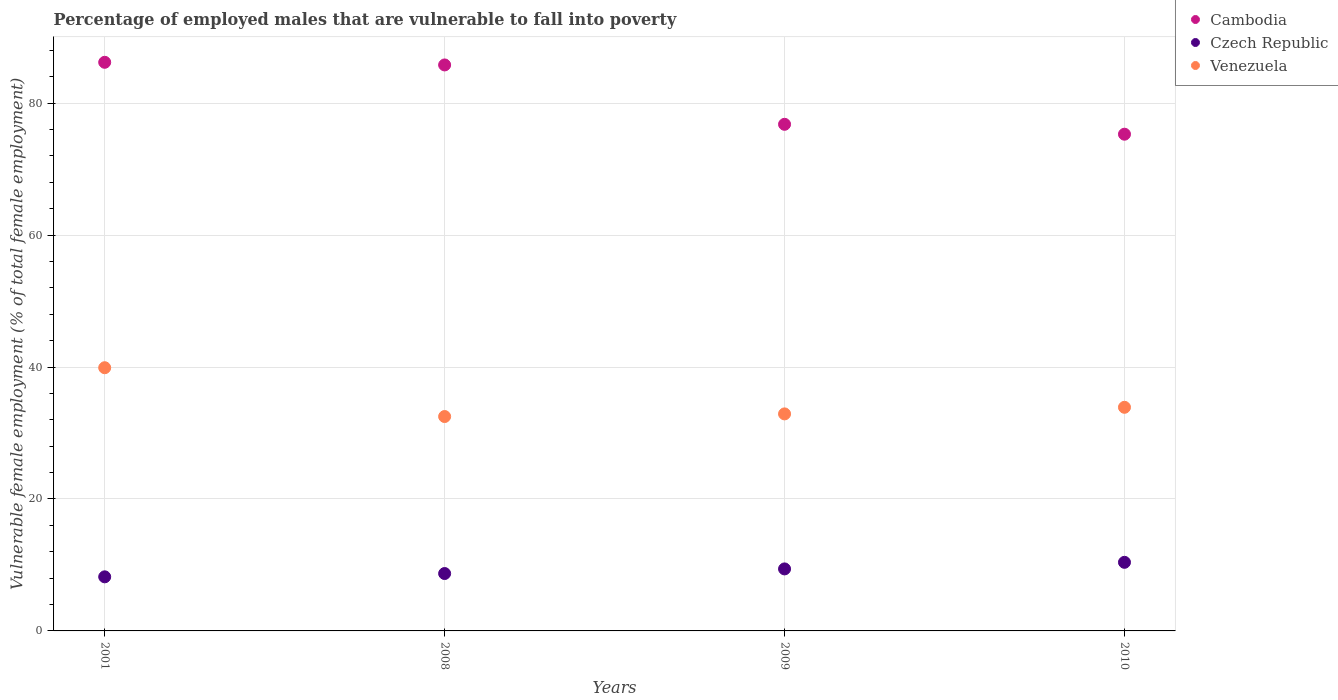What is the percentage of employed males who are vulnerable to fall into poverty in Cambodia in 2008?
Provide a succinct answer. 85.8. Across all years, what is the maximum percentage of employed males who are vulnerable to fall into poverty in Czech Republic?
Provide a succinct answer. 10.4. Across all years, what is the minimum percentage of employed males who are vulnerable to fall into poverty in Venezuela?
Offer a terse response. 32.5. In which year was the percentage of employed males who are vulnerable to fall into poverty in Cambodia minimum?
Offer a very short reply. 2010. What is the total percentage of employed males who are vulnerable to fall into poverty in Cambodia in the graph?
Keep it short and to the point. 324.1. What is the difference between the percentage of employed males who are vulnerable to fall into poverty in Venezuela in 2008 and that in 2009?
Make the answer very short. -0.4. What is the difference between the percentage of employed males who are vulnerable to fall into poverty in Czech Republic in 2010 and the percentage of employed males who are vulnerable to fall into poverty in Venezuela in 2008?
Provide a short and direct response. -22.1. What is the average percentage of employed males who are vulnerable to fall into poverty in Cambodia per year?
Your response must be concise. 81.03. In the year 2010, what is the difference between the percentage of employed males who are vulnerable to fall into poverty in Cambodia and percentage of employed males who are vulnerable to fall into poverty in Czech Republic?
Offer a terse response. 64.9. What is the ratio of the percentage of employed males who are vulnerable to fall into poverty in Cambodia in 2001 to that in 2010?
Ensure brevity in your answer.  1.14. Is the percentage of employed males who are vulnerable to fall into poverty in Cambodia in 2008 less than that in 2010?
Make the answer very short. No. What is the difference between the highest and the second highest percentage of employed males who are vulnerable to fall into poverty in Czech Republic?
Provide a short and direct response. 1. What is the difference between the highest and the lowest percentage of employed males who are vulnerable to fall into poverty in Czech Republic?
Give a very brief answer. 2.2. In how many years, is the percentage of employed males who are vulnerable to fall into poverty in Venezuela greater than the average percentage of employed males who are vulnerable to fall into poverty in Venezuela taken over all years?
Your answer should be very brief. 1. Is the sum of the percentage of employed males who are vulnerable to fall into poverty in Venezuela in 2001 and 2010 greater than the maximum percentage of employed males who are vulnerable to fall into poverty in Czech Republic across all years?
Offer a terse response. Yes. Is the percentage of employed males who are vulnerable to fall into poverty in Cambodia strictly less than the percentage of employed males who are vulnerable to fall into poverty in Czech Republic over the years?
Provide a short and direct response. No. How many dotlines are there?
Provide a short and direct response. 3. How many years are there in the graph?
Your answer should be very brief. 4. What is the difference between two consecutive major ticks on the Y-axis?
Give a very brief answer. 20. Are the values on the major ticks of Y-axis written in scientific E-notation?
Your answer should be very brief. No. Does the graph contain any zero values?
Your response must be concise. No. Does the graph contain grids?
Your response must be concise. Yes. Where does the legend appear in the graph?
Make the answer very short. Top right. How many legend labels are there?
Your answer should be compact. 3. How are the legend labels stacked?
Make the answer very short. Vertical. What is the title of the graph?
Your response must be concise. Percentage of employed males that are vulnerable to fall into poverty. What is the label or title of the X-axis?
Provide a short and direct response. Years. What is the label or title of the Y-axis?
Ensure brevity in your answer.  Vulnerable female employment (% of total female employment). What is the Vulnerable female employment (% of total female employment) in Cambodia in 2001?
Provide a succinct answer. 86.2. What is the Vulnerable female employment (% of total female employment) of Czech Republic in 2001?
Offer a terse response. 8.2. What is the Vulnerable female employment (% of total female employment) of Venezuela in 2001?
Your answer should be very brief. 39.9. What is the Vulnerable female employment (% of total female employment) in Cambodia in 2008?
Your answer should be compact. 85.8. What is the Vulnerable female employment (% of total female employment) of Czech Republic in 2008?
Make the answer very short. 8.7. What is the Vulnerable female employment (% of total female employment) of Venezuela in 2008?
Give a very brief answer. 32.5. What is the Vulnerable female employment (% of total female employment) in Cambodia in 2009?
Make the answer very short. 76.8. What is the Vulnerable female employment (% of total female employment) in Czech Republic in 2009?
Provide a short and direct response. 9.4. What is the Vulnerable female employment (% of total female employment) in Venezuela in 2009?
Your answer should be compact. 32.9. What is the Vulnerable female employment (% of total female employment) in Cambodia in 2010?
Provide a succinct answer. 75.3. What is the Vulnerable female employment (% of total female employment) in Czech Republic in 2010?
Your response must be concise. 10.4. What is the Vulnerable female employment (% of total female employment) of Venezuela in 2010?
Your answer should be very brief. 33.9. Across all years, what is the maximum Vulnerable female employment (% of total female employment) in Cambodia?
Your response must be concise. 86.2. Across all years, what is the maximum Vulnerable female employment (% of total female employment) of Czech Republic?
Keep it short and to the point. 10.4. Across all years, what is the maximum Vulnerable female employment (% of total female employment) of Venezuela?
Your response must be concise. 39.9. Across all years, what is the minimum Vulnerable female employment (% of total female employment) in Cambodia?
Make the answer very short. 75.3. Across all years, what is the minimum Vulnerable female employment (% of total female employment) of Czech Republic?
Keep it short and to the point. 8.2. Across all years, what is the minimum Vulnerable female employment (% of total female employment) in Venezuela?
Keep it short and to the point. 32.5. What is the total Vulnerable female employment (% of total female employment) in Cambodia in the graph?
Ensure brevity in your answer.  324.1. What is the total Vulnerable female employment (% of total female employment) of Czech Republic in the graph?
Provide a succinct answer. 36.7. What is the total Vulnerable female employment (% of total female employment) of Venezuela in the graph?
Offer a terse response. 139.2. What is the difference between the Vulnerable female employment (% of total female employment) in Czech Republic in 2001 and that in 2008?
Provide a short and direct response. -0.5. What is the difference between the Vulnerable female employment (% of total female employment) in Venezuela in 2001 and that in 2008?
Offer a terse response. 7.4. What is the difference between the Vulnerable female employment (% of total female employment) in Cambodia in 2001 and that in 2009?
Make the answer very short. 9.4. What is the difference between the Vulnerable female employment (% of total female employment) of Venezuela in 2001 and that in 2009?
Offer a very short reply. 7. What is the difference between the Vulnerable female employment (% of total female employment) of Cambodia in 2001 and that in 2010?
Your answer should be very brief. 10.9. What is the difference between the Vulnerable female employment (% of total female employment) of Czech Republic in 2001 and that in 2010?
Make the answer very short. -2.2. What is the difference between the Vulnerable female employment (% of total female employment) of Venezuela in 2001 and that in 2010?
Offer a very short reply. 6. What is the difference between the Vulnerable female employment (% of total female employment) of Cambodia in 2008 and that in 2009?
Provide a succinct answer. 9. What is the difference between the Vulnerable female employment (% of total female employment) of Cambodia in 2008 and that in 2010?
Make the answer very short. 10.5. What is the difference between the Vulnerable female employment (% of total female employment) in Czech Republic in 2008 and that in 2010?
Keep it short and to the point. -1.7. What is the difference between the Vulnerable female employment (% of total female employment) in Venezuela in 2008 and that in 2010?
Keep it short and to the point. -1.4. What is the difference between the Vulnerable female employment (% of total female employment) of Cambodia in 2009 and that in 2010?
Provide a short and direct response. 1.5. What is the difference between the Vulnerable female employment (% of total female employment) in Czech Republic in 2009 and that in 2010?
Make the answer very short. -1. What is the difference between the Vulnerable female employment (% of total female employment) of Venezuela in 2009 and that in 2010?
Provide a short and direct response. -1. What is the difference between the Vulnerable female employment (% of total female employment) of Cambodia in 2001 and the Vulnerable female employment (% of total female employment) of Czech Republic in 2008?
Give a very brief answer. 77.5. What is the difference between the Vulnerable female employment (% of total female employment) in Cambodia in 2001 and the Vulnerable female employment (% of total female employment) in Venezuela in 2008?
Provide a succinct answer. 53.7. What is the difference between the Vulnerable female employment (% of total female employment) in Czech Republic in 2001 and the Vulnerable female employment (% of total female employment) in Venezuela in 2008?
Your response must be concise. -24.3. What is the difference between the Vulnerable female employment (% of total female employment) of Cambodia in 2001 and the Vulnerable female employment (% of total female employment) of Czech Republic in 2009?
Offer a very short reply. 76.8. What is the difference between the Vulnerable female employment (% of total female employment) in Cambodia in 2001 and the Vulnerable female employment (% of total female employment) in Venezuela in 2009?
Your answer should be very brief. 53.3. What is the difference between the Vulnerable female employment (% of total female employment) of Czech Republic in 2001 and the Vulnerable female employment (% of total female employment) of Venezuela in 2009?
Your response must be concise. -24.7. What is the difference between the Vulnerable female employment (% of total female employment) of Cambodia in 2001 and the Vulnerable female employment (% of total female employment) of Czech Republic in 2010?
Offer a terse response. 75.8. What is the difference between the Vulnerable female employment (% of total female employment) in Cambodia in 2001 and the Vulnerable female employment (% of total female employment) in Venezuela in 2010?
Offer a terse response. 52.3. What is the difference between the Vulnerable female employment (% of total female employment) of Czech Republic in 2001 and the Vulnerable female employment (% of total female employment) of Venezuela in 2010?
Your answer should be compact. -25.7. What is the difference between the Vulnerable female employment (% of total female employment) in Cambodia in 2008 and the Vulnerable female employment (% of total female employment) in Czech Republic in 2009?
Offer a terse response. 76.4. What is the difference between the Vulnerable female employment (% of total female employment) of Cambodia in 2008 and the Vulnerable female employment (% of total female employment) of Venezuela in 2009?
Make the answer very short. 52.9. What is the difference between the Vulnerable female employment (% of total female employment) of Czech Republic in 2008 and the Vulnerable female employment (% of total female employment) of Venezuela in 2009?
Keep it short and to the point. -24.2. What is the difference between the Vulnerable female employment (% of total female employment) of Cambodia in 2008 and the Vulnerable female employment (% of total female employment) of Czech Republic in 2010?
Provide a short and direct response. 75.4. What is the difference between the Vulnerable female employment (% of total female employment) of Cambodia in 2008 and the Vulnerable female employment (% of total female employment) of Venezuela in 2010?
Give a very brief answer. 51.9. What is the difference between the Vulnerable female employment (% of total female employment) of Czech Republic in 2008 and the Vulnerable female employment (% of total female employment) of Venezuela in 2010?
Ensure brevity in your answer.  -25.2. What is the difference between the Vulnerable female employment (% of total female employment) in Cambodia in 2009 and the Vulnerable female employment (% of total female employment) in Czech Republic in 2010?
Provide a short and direct response. 66.4. What is the difference between the Vulnerable female employment (% of total female employment) of Cambodia in 2009 and the Vulnerable female employment (% of total female employment) of Venezuela in 2010?
Your answer should be compact. 42.9. What is the difference between the Vulnerable female employment (% of total female employment) of Czech Republic in 2009 and the Vulnerable female employment (% of total female employment) of Venezuela in 2010?
Offer a very short reply. -24.5. What is the average Vulnerable female employment (% of total female employment) in Cambodia per year?
Your answer should be very brief. 81.03. What is the average Vulnerable female employment (% of total female employment) of Czech Republic per year?
Provide a succinct answer. 9.18. What is the average Vulnerable female employment (% of total female employment) in Venezuela per year?
Give a very brief answer. 34.8. In the year 2001, what is the difference between the Vulnerable female employment (% of total female employment) in Cambodia and Vulnerable female employment (% of total female employment) in Venezuela?
Keep it short and to the point. 46.3. In the year 2001, what is the difference between the Vulnerable female employment (% of total female employment) in Czech Republic and Vulnerable female employment (% of total female employment) in Venezuela?
Provide a short and direct response. -31.7. In the year 2008, what is the difference between the Vulnerable female employment (% of total female employment) of Cambodia and Vulnerable female employment (% of total female employment) of Czech Republic?
Ensure brevity in your answer.  77.1. In the year 2008, what is the difference between the Vulnerable female employment (% of total female employment) in Cambodia and Vulnerable female employment (% of total female employment) in Venezuela?
Ensure brevity in your answer.  53.3. In the year 2008, what is the difference between the Vulnerable female employment (% of total female employment) of Czech Republic and Vulnerable female employment (% of total female employment) of Venezuela?
Offer a terse response. -23.8. In the year 2009, what is the difference between the Vulnerable female employment (% of total female employment) in Cambodia and Vulnerable female employment (% of total female employment) in Czech Republic?
Your answer should be very brief. 67.4. In the year 2009, what is the difference between the Vulnerable female employment (% of total female employment) of Cambodia and Vulnerable female employment (% of total female employment) of Venezuela?
Offer a terse response. 43.9. In the year 2009, what is the difference between the Vulnerable female employment (% of total female employment) in Czech Republic and Vulnerable female employment (% of total female employment) in Venezuela?
Ensure brevity in your answer.  -23.5. In the year 2010, what is the difference between the Vulnerable female employment (% of total female employment) in Cambodia and Vulnerable female employment (% of total female employment) in Czech Republic?
Your response must be concise. 64.9. In the year 2010, what is the difference between the Vulnerable female employment (% of total female employment) of Cambodia and Vulnerable female employment (% of total female employment) of Venezuela?
Give a very brief answer. 41.4. In the year 2010, what is the difference between the Vulnerable female employment (% of total female employment) of Czech Republic and Vulnerable female employment (% of total female employment) of Venezuela?
Your answer should be compact. -23.5. What is the ratio of the Vulnerable female employment (% of total female employment) in Cambodia in 2001 to that in 2008?
Ensure brevity in your answer.  1. What is the ratio of the Vulnerable female employment (% of total female employment) of Czech Republic in 2001 to that in 2008?
Make the answer very short. 0.94. What is the ratio of the Vulnerable female employment (% of total female employment) in Venezuela in 2001 to that in 2008?
Provide a short and direct response. 1.23. What is the ratio of the Vulnerable female employment (% of total female employment) in Cambodia in 2001 to that in 2009?
Your response must be concise. 1.12. What is the ratio of the Vulnerable female employment (% of total female employment) in Czech Republic in 2001 to that in 2009?
Your answer should be compact. 0.87. What is the ratio of the Vulnerable female employment (% of total female employment) of Venezuela in 2001 to that in 2009?
Provide a short and direct response. 1.21. What is the ratio of the Vulnerable female employment (% of total female employment) in Cambodia in 2001 to that in 2010?
Your response must be concise. 1.14. What is the ratio of the Vulnerable female employment (% of total female employment) in Czech Republic in 2001 to that in 2010?
Provide a short and direct response. 0.79. What is the ratio of the Vulnerable female employment (% of total female employment) of Venezuela in 2001 to that in 2010?
Your answer should be compact. 1.18. What is the ratio of the Vulnerable female employment (% of total female employment) in Cambodia in 2008 to that in 2009?
Your response must be concise. 1.12. What is the ratio of the Vulnerable female employment (% of total female employment) of Czech Republic in 2008 to that in 2009?
Make the answer very short. 0.93. What is the ratio of the Vulnerable female employment (% of total female employment) in Cambodia in 2008 to that in 2010?
Provide a succinct answer. 1.14. What is the ratio of the Vulnerable female employment (% of total female employment) in Czech Republic in 2008 to that in 2010?
Provide a short and direct response. 0.84. What is the ratio of the Vulnerable female employment (% of total female employment) in Venezuela in 2008 to that in 2010?
Keep it short and to the point. 0.96. What is the ratio of the Vulnerable female employment (% of total female employment) in Cambodia in 2009 to that in 2010?
Offer a terse response. 1.02. What is the ratio of the Vulnerable female employment (% of total female employment) of Czech Republic in 2009 to that in 2010?
Offer a terse response. 0.9. What is the ratio of the Vulnerable female employment (% of total female employment) of Venezuela in 2009 to that in 2010?
Provide a short and direct response. 0.97. What is the difference between the highest and the second highest Vulnerable female employment (% of total female employment) of Venezuela?
Your answer should be compact. 6. What is the difference between the highest and the lowest Vulnerable female employment (% of total female employment) in Cambodia?
Your answer should be very brief. 10.9. What is the difference between the highest and the lowest Vulnerable female employment (% of total female employment) in Czech Republic?
Ensure brevity in your answer.  2.2. What is the difference between the highest and the lowest Vulnerable female employment (% of total female employment) in Venezuela?
Offer a terse response. 7.4. 